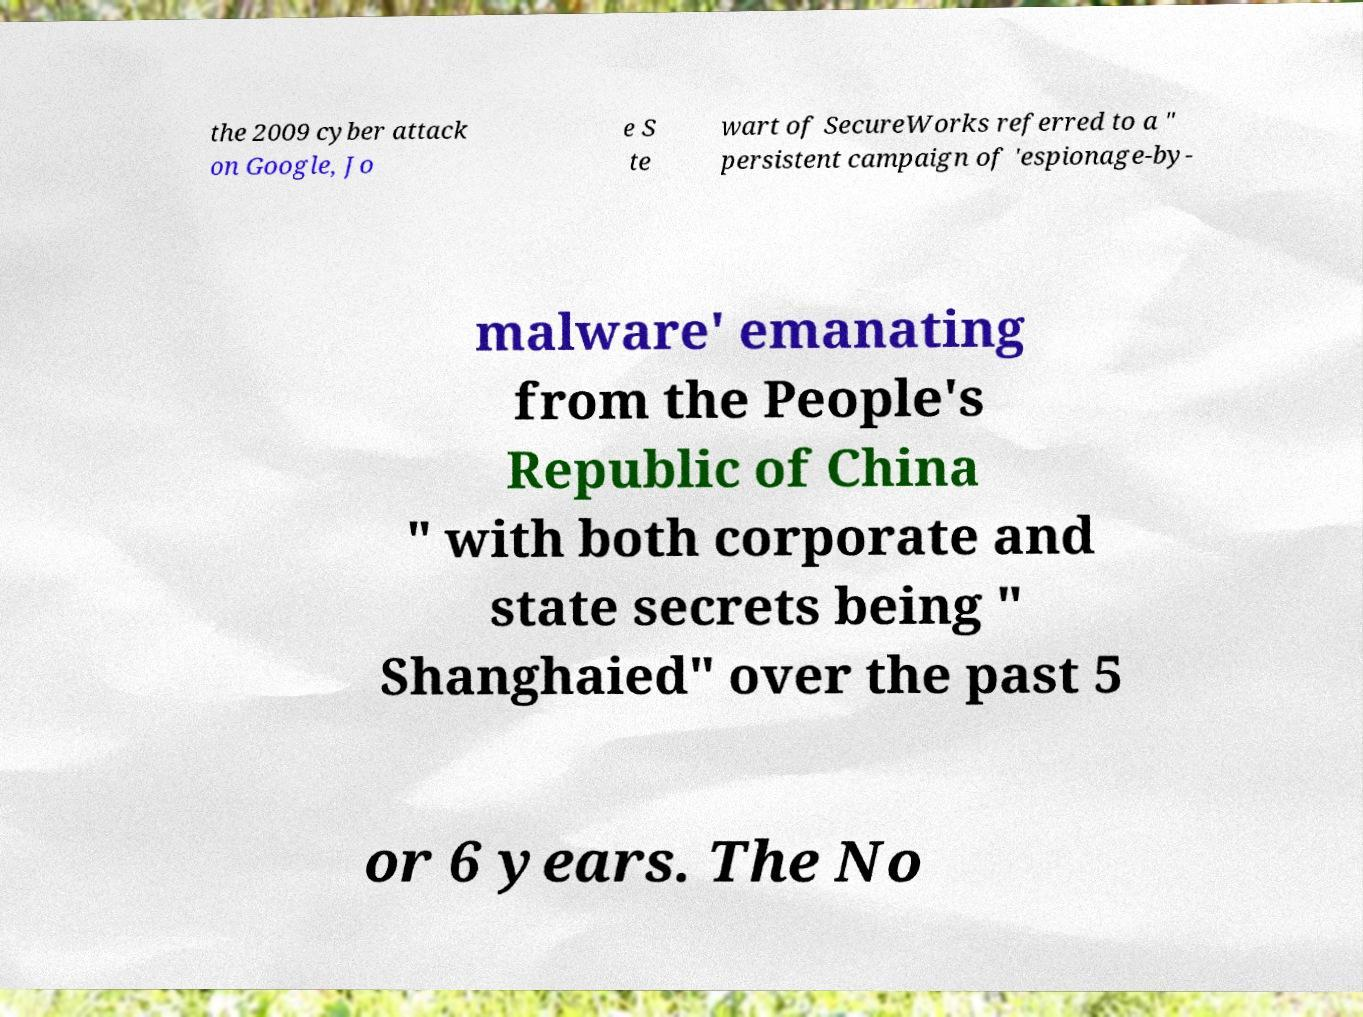Can you read and provide the text displayed in the image?This photo seems to have some interesting text. Can you extract and type it out for me? the 2009 cyber attack on Google, Jo e S te wart of SecureWorks referred to a " persistent campaign of 'espionage-by- malware' emanating from the People's Republic of China " with both corporate and state secrets being " Shanghaied" over the past 5 or 6 years. The No 